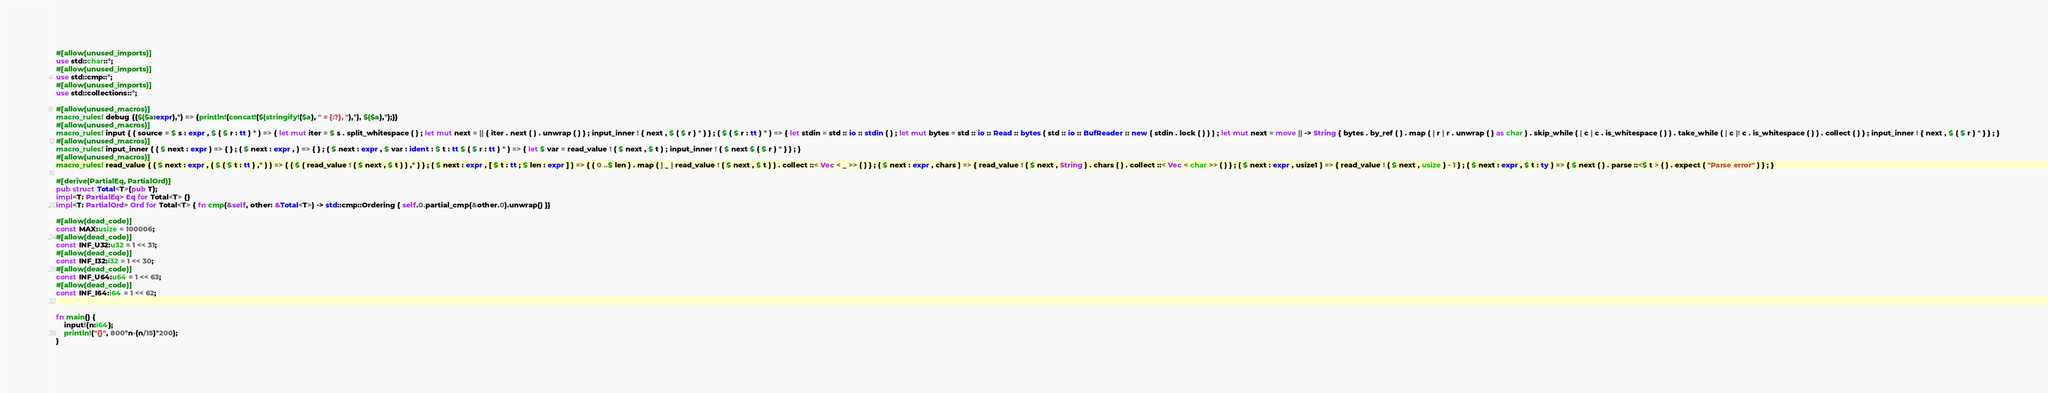<code> <loc_0><loc_0><loc_500><loc_500><_Rust_>#[allow(unused_imports)]
use std::char::*;
#[allow(unused_imports)]
use std::cmp::*;
#[allow(unused_imports)]
use std::collections::*;

#[allow(unused_macros)]
macro_rules! debug {($($a:expr),*) => {println!(concat!($(stringify!($a), " = {:?}, "),*), $($a),*);}}
#[allow(unused_macros)]
macro_rules! input { ( source = $ s : expr , $ ( $ r : tt ) * ) => { let mut iter = $ s . split_whitespace ( ) ; let mut next = || { iter . next ( ) . unwrap ( ) } ; input_inner ! { next , $ ( $ r ) * } } ; ( $ ( $ r : tt ) * ) => { let stdin = std :: io :: stdin ( ) ; let mut bytes = std :: io :: Read :: bytes ( std :: io :: BufReader :: new ( stdin . lock ( ) ) ) ; let mut next = move || -> String { bytes . by_ref ( ) . map ( | r | r . unwrap ( ) as char ) . skip_while ( | c | c . is_whitespace ( ) ) . take_while ( | c |! c . is_whitespace ( ) ) . collect ( ) } ; input_inner ! { next , $ ( $ r ) * } } ; }
#[allow(unused_macros)]
macro_rules! input_inner { ( $ next : expr ) => { } ; ( $ next : expr , ) => { } ; ( $ next : expr , $ var : ident : $ t : tt $ ( $ r : tt ) * ) => { let $ var = read_value ! ( $ next , $ t ) ; input_inner ! { $ next $ ( $ r ) * } } ; }
#[allow(unused_macros)]
macro_rules! read_value { ( $ next : expr , ( $ ( $ t : tt ) ,* ) ) => { ( $ ( read_value ! ( $ next , $ t ) ) ,* ) } ; ( $ next : expr , [ $ t : tt ; $ len : expr ] ) => { ( 0 ..$ len ) . map ( | _ | read_value ! ( $ next , $ t ) ) . collect ::< Vec < _ >> ( ) } ; ( $ next : expr , chars ) => { read_value ! ( $ next , String ) . chars ( ) . collect ::< Vec < char >> ( ) } ; ( $ next : expr , usize1 ) => { read_value ! ( $ next , usize ) - 1 } ; ( $ next : expr , $ t : ty ) => { $ next ( ) . parse ::<$ t > ( ) . expect ( "Parse error" ) } ; }

#[derive(PartialEq, PartialOrd)]
pub struct Total<T>(pub T);
impl<T: PartialEq> Eq for Total<T> {}
impl<T: PartialOrd> Ord for Total<T> { fn cmp(&self, other: &Total<T>) -> std::cmp::Ordering { self.0.partial_cmp(&other.0).unwrap() }}

#[allow(dead_code)]
const MAX:usize = 100006;
#[allow(dead_code)]
const INF_U32:u32 = 1 << 31;
#[allow(dead_code)]
const INF_I32:i32 = 1 << 30;
#[allow(dead_code)]
const INF_U64:u64 = 1 << 63;
#[allow(dead_code)]
const INF_I64:i64 = 1 << 62;


fn main() {
    input!{n:i64};
    println!("{}", 800*n-(n/15)*200);
}
</code> 